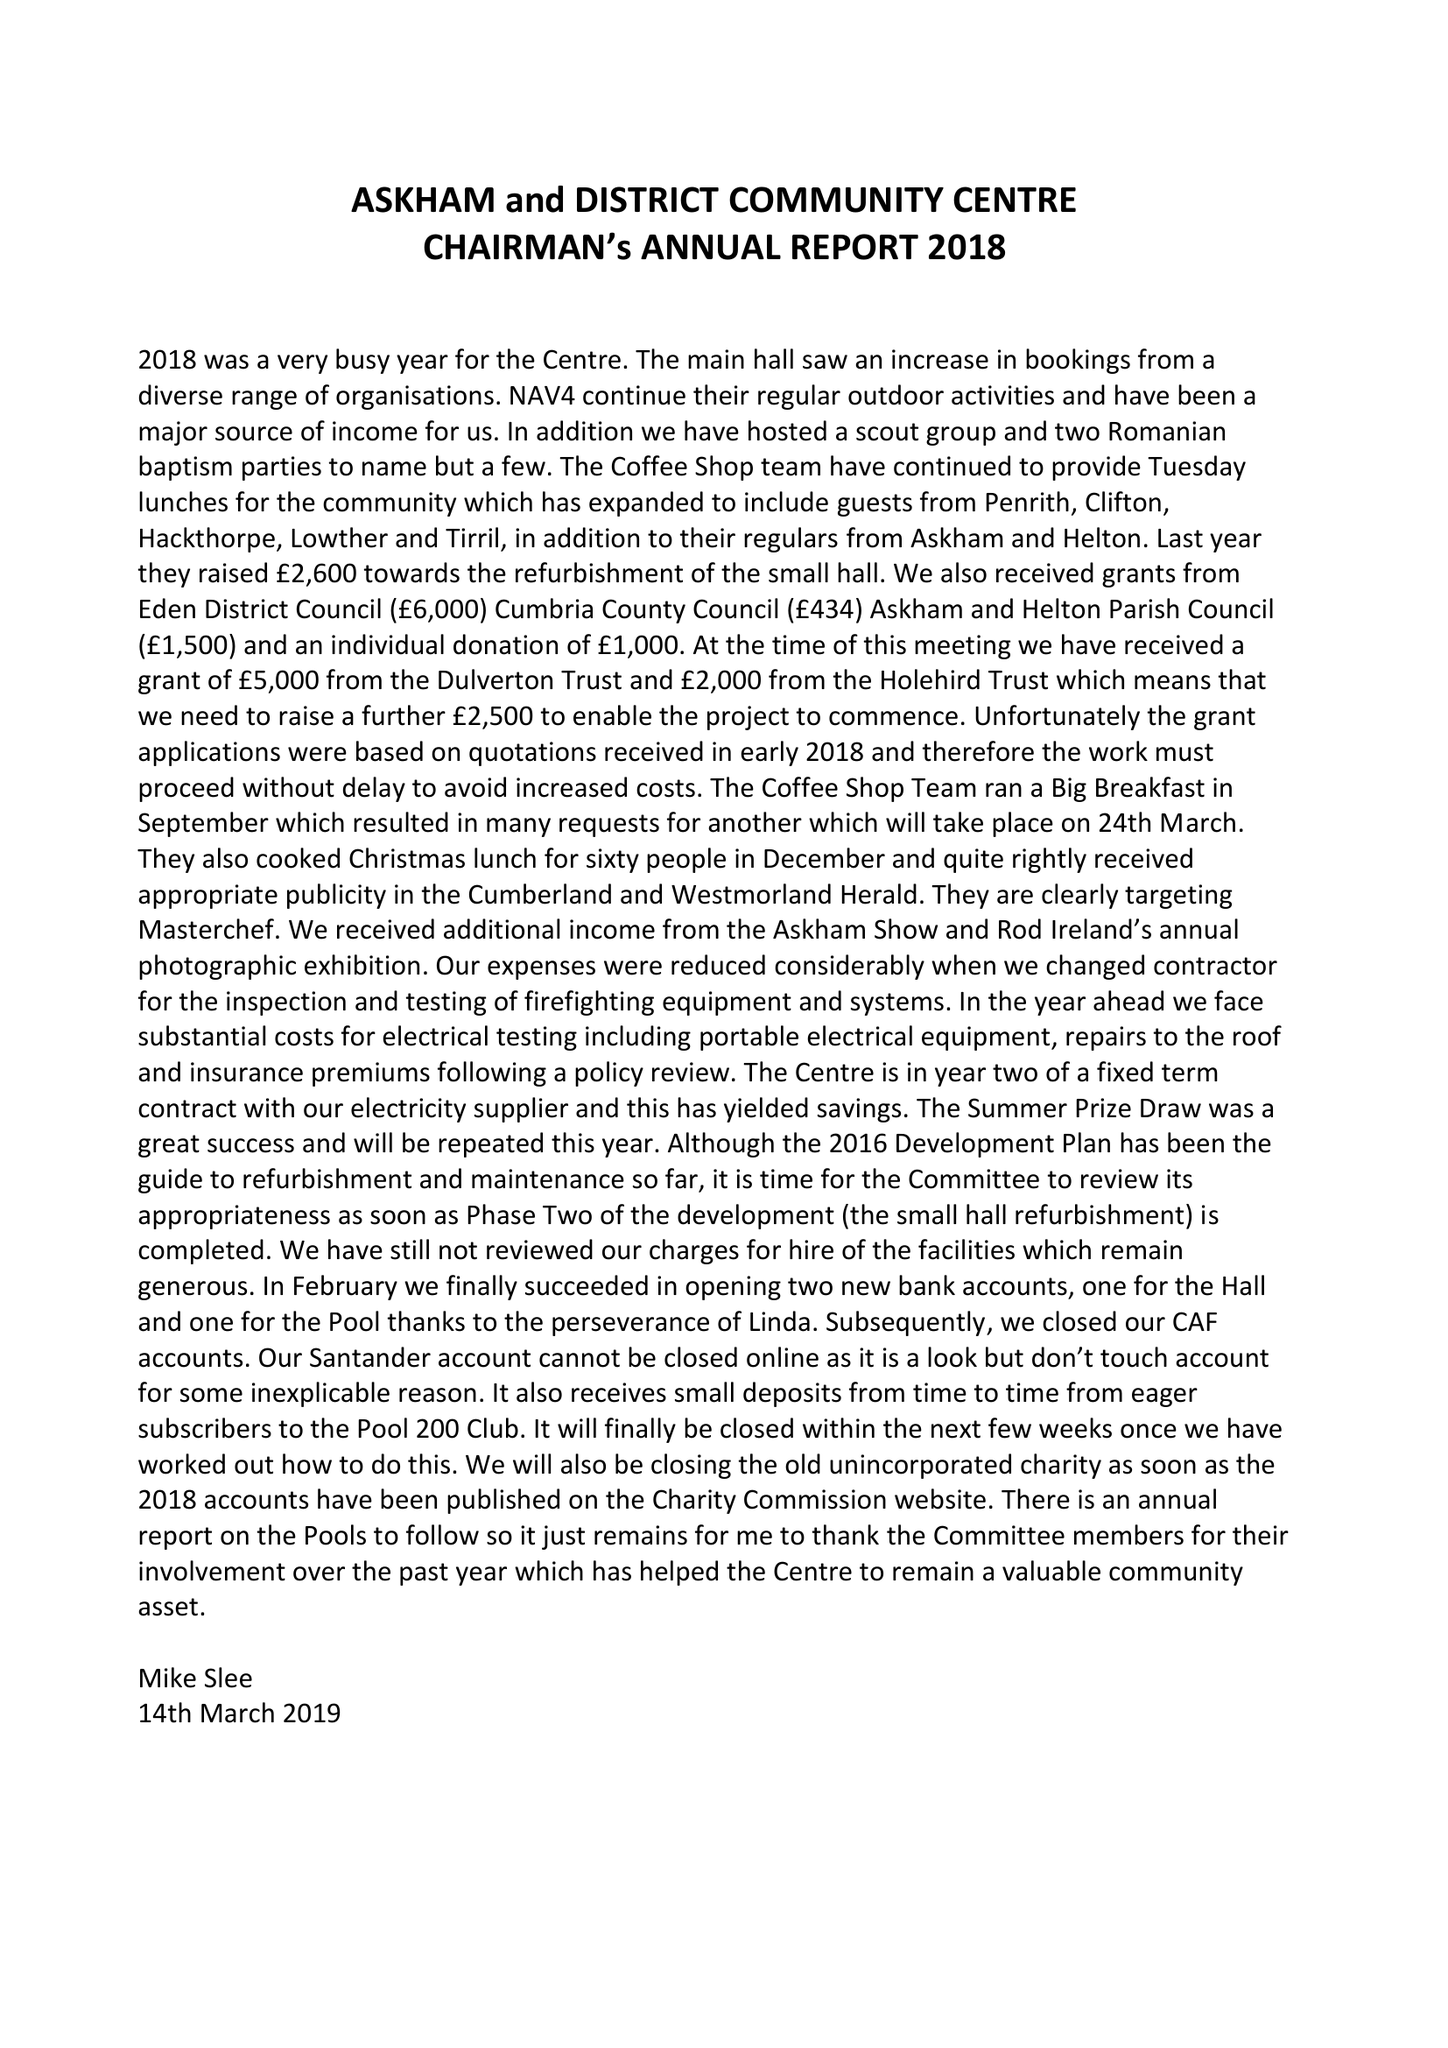What is the value for the address__street_line?
Answer the question using a single word or phrase. ELM BANK 